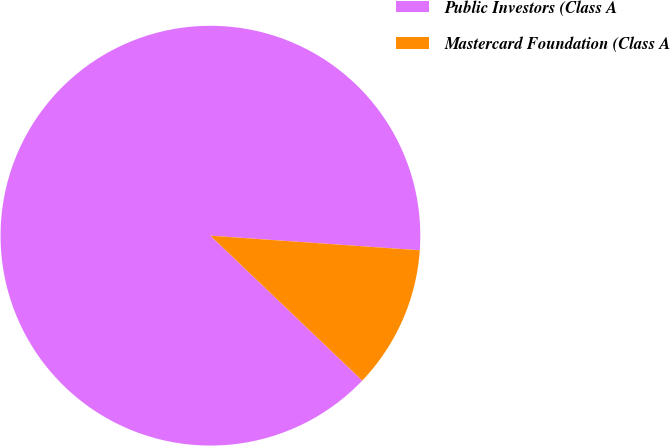Convert chart to OTSL. <chart><loc_0><loc_0><loc_500><loc_500><pie_chart><fcel>Public Investors (Class A<fcel>Mastercard Foundation (Class A<nl><fcel>88.98%<fcel>11.02%<nl></chart> 